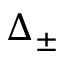<formula> <loc_0><loc_0><loc_500><loc_500>\Delta _ { \pm }</formula> 